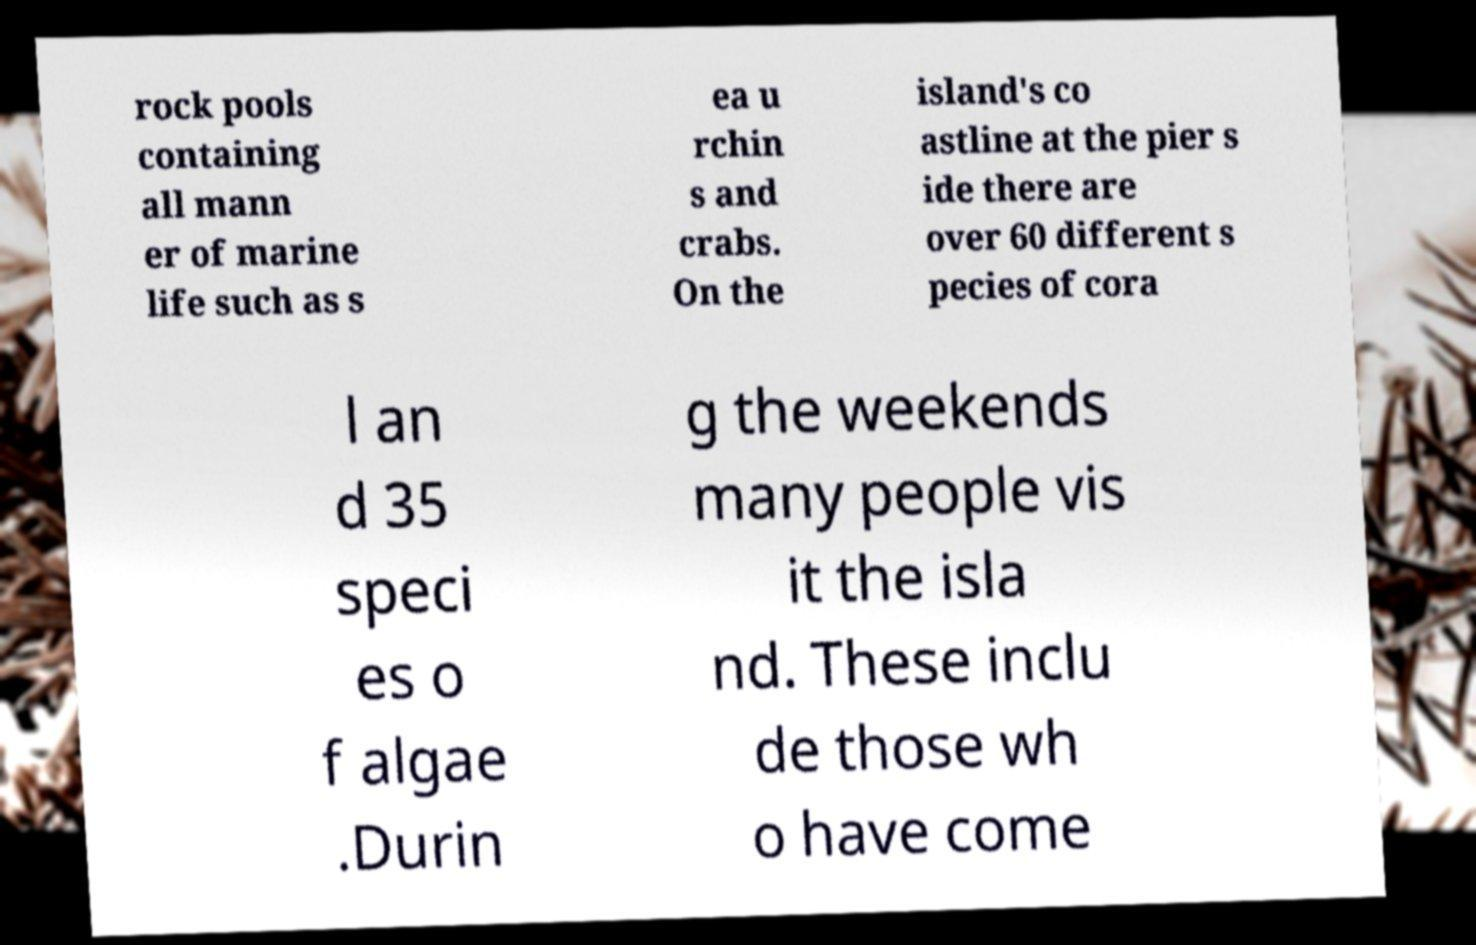For documentation purposes, I need the text within this image transcribed. Could you provide that? rock pools containing all mann er of marine life such as s ea u rchin s and crabs. On the island's co astline at the pier s ide there are over 60 different s pecies of cora l an d 35 speci es o f algae .Durin g the weekends many people vis it the isla nd. These inclu de those wh o have come 